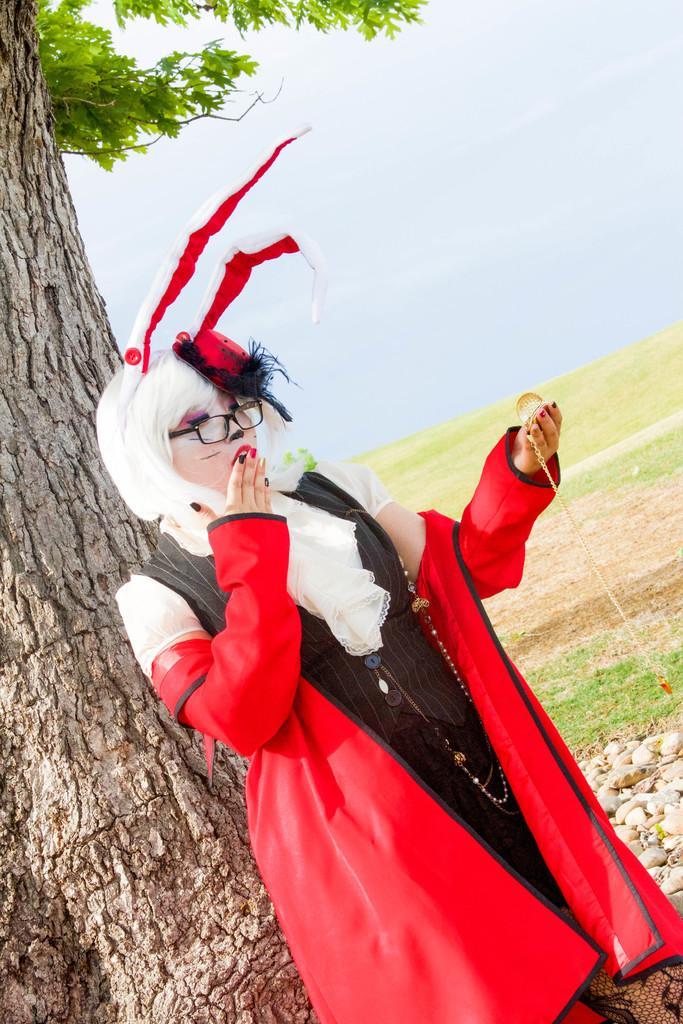Could you give a brief overview of what you see in this image? In the image in the center, we can see one person standing and holding some object. In the background, we can see the sky, one tree and grass. 